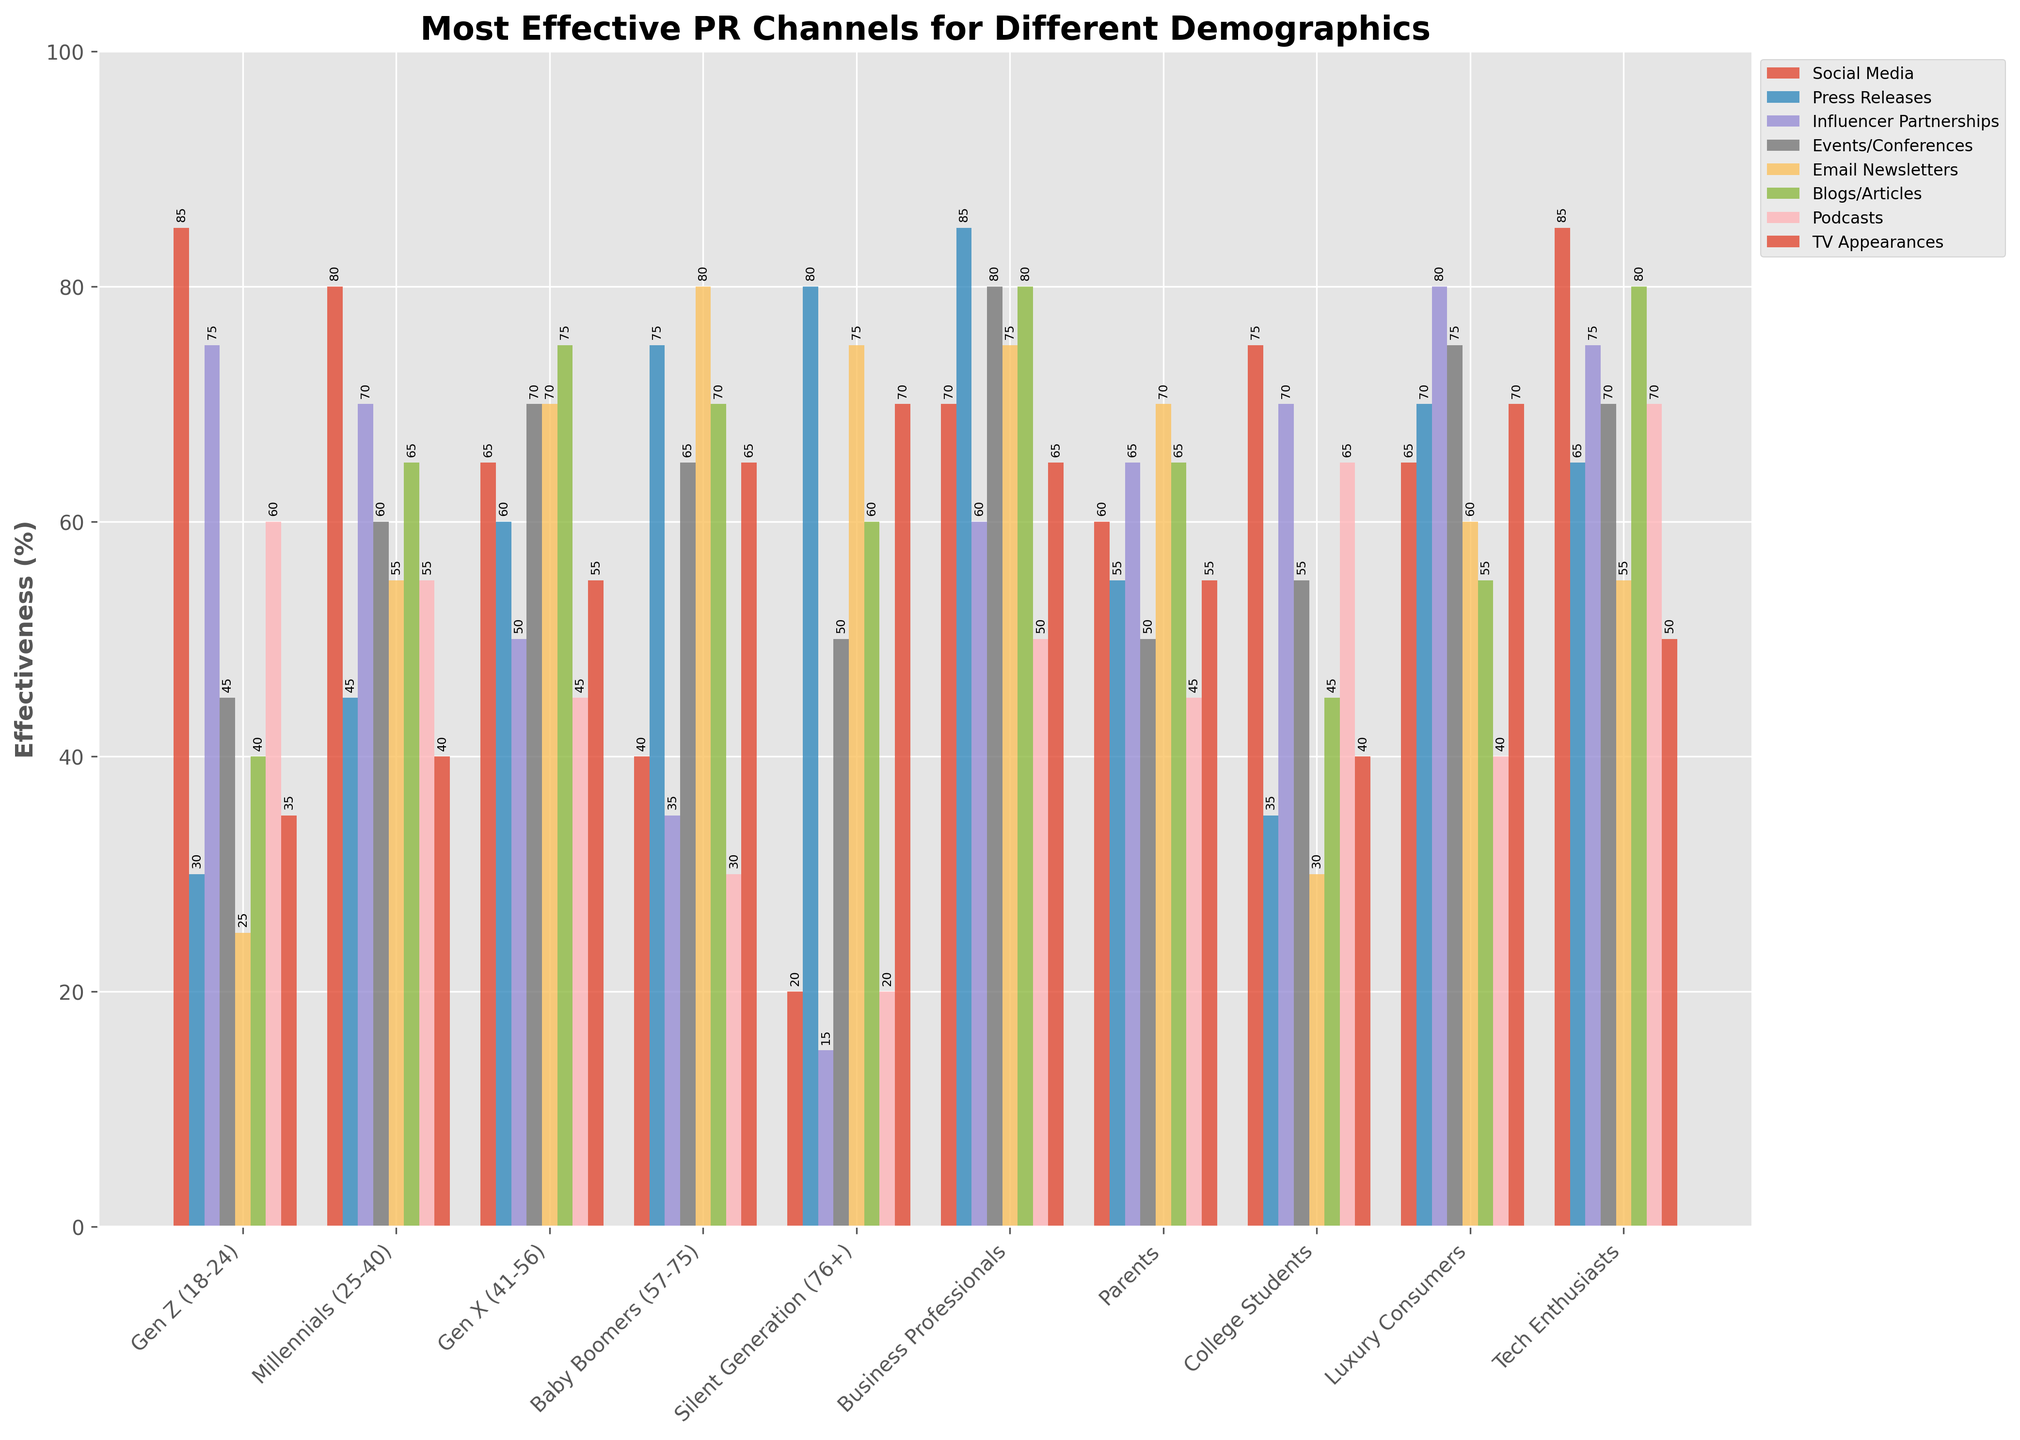Which demographic finds Social Media the most effective? The bar representing Social Media effectiveness is highest for Gen Z (18-24).
Answer: Gen Z (18-24) Among Baby Boomers (57-75), which PR channel is perceived to be the least effective? The bar for Social Media is the shortest within the Baby Boomers category.
Answer: Social Media Which two demographics find Email Newsletters equally effective? The bars for Email Newsletters effectiveness are at the same height for Gen X (41-56) and Parents.
Answer: Gen X (41-56) and Parents Which PR channel do Business Professionals find most effective? The tallest bar within the Business Professionals category corresponds to Press Releases.
Answer: Press Releases How does the effectiveness of Blogs/Articles compare between Millennials (25-40) and Silent Generation (76+)? The bar for Blogs/Articles is higher for Millennials (25-40) compared to Silent Generation (76+).
Answer: More effective for Millennials (25-40) Which demographic finds Influencer Partnerships and TV Appearances equally effective? Both bars for Influencer Partnerships and TV Appearances are of the same height for College Students.
Answer: College Students What is the average effectiveness of Podcasts for Gen Z (18-24) and Tech Enthusiasts? Adding the effectiveness for Gen Z (60) and Tech Enthusiasts (70), sums to 130. The average is 130/2 = 65.
Answer: 65 Compare the effectiveness of Events/Conferences for Gen X (41-56) and Luxury Consumers. Who finds it more effective? The bar for Events/Conferences is higher for Luxury Consumers than for Gen X.
Answer: Luxury Consumers What is the total effectiveness score for Social Media across all demographics? Summing up the effectiveness scores for Social Media across all demographics (85+80+65+40+20+70+60+75+65+85), the total is 645.
Answer: 645 Which demographic finds TV Appearances more effective than Podcasts? Comparing the heights of the bars for TV Appearances and Podcasts, the TV Appearances bar is higher for Gen X (41-56).
Answer: Gen X (41-56) 